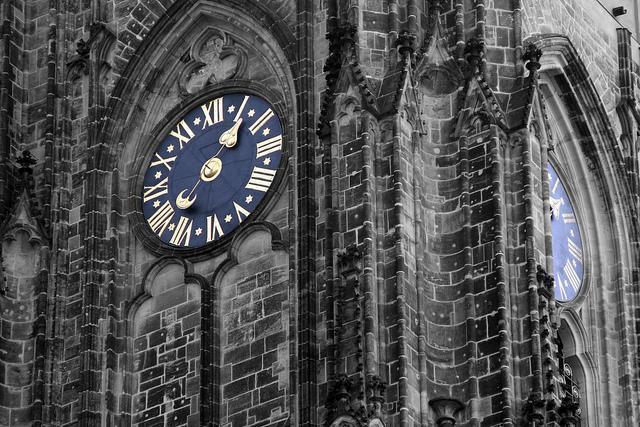How many clocks can you see?
Give a very brief answer. 2. 